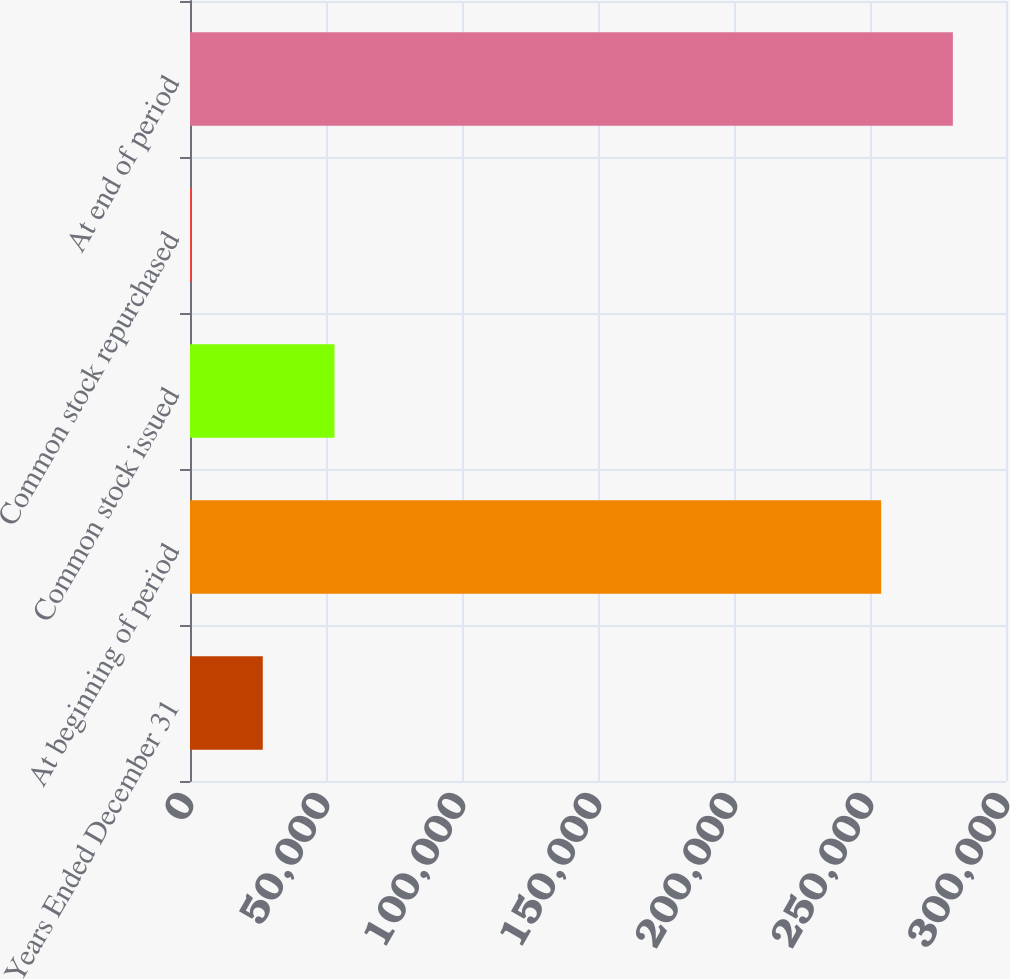Convert chart to OTSL. <chart><loc_0><loc_0><loc_500><loc_500><bar_chart><fcel>Years Ended December 31<fcel>At beginning of period<fcel>Common stock issued<fcel>Common stock repurchased<fcel>At end of period<nl><fcel>26757.3<fcel>254100<fcel>53125.6<fcel>389<fcel>280468<nl></chart> 